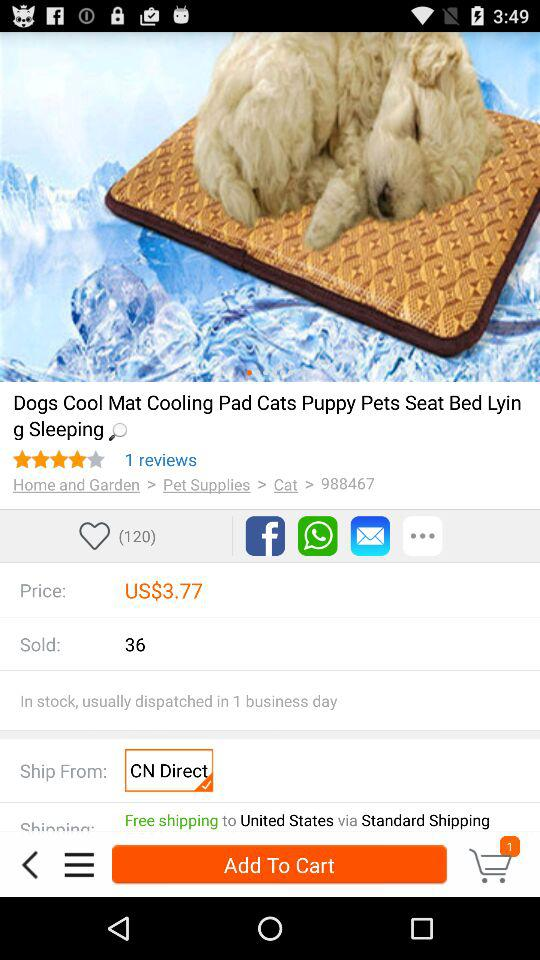What is the total number of sold dogs cool mat cooling pad? The total is 36. 